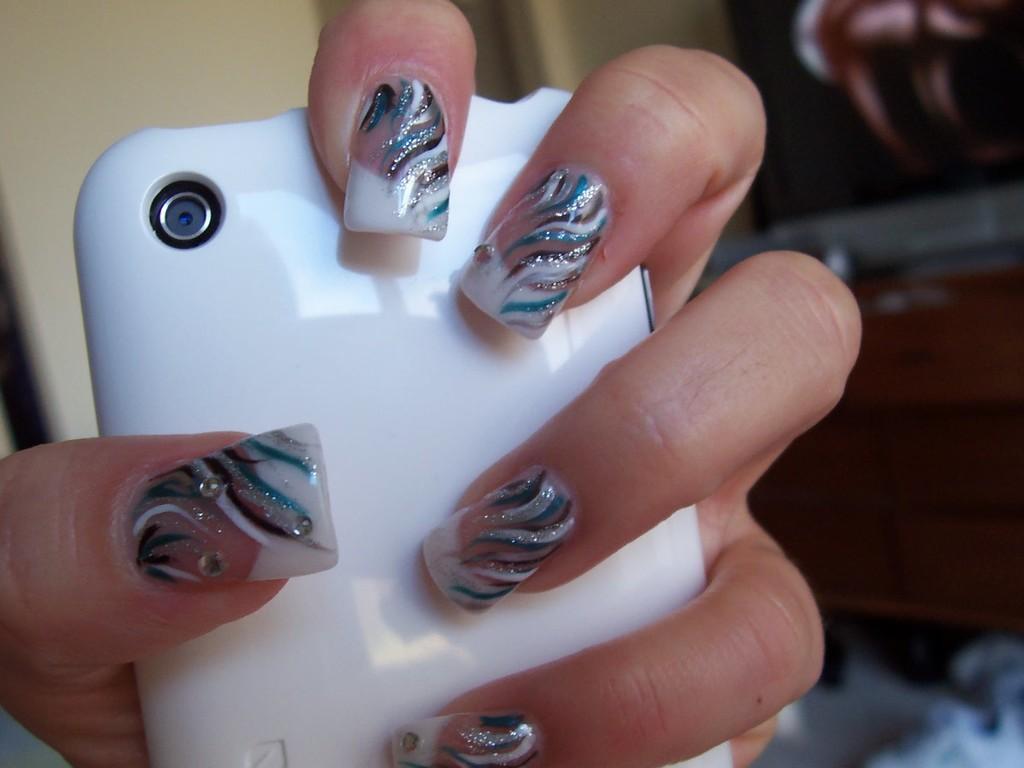In one or two sentences, can you explain what this image depicts? In this image we can see a person hand holding a cellphone with some blurry background. 